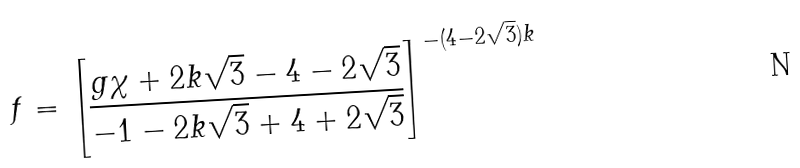<formula> <loc_0><loc_0><loc_500><loc_500>f = \left [ \frac { g \chi + 2 k \sqrt { 3 } - 4 - 2 \sqrt { 3 } } { - 1 - 2 k \sqrt { 3 } + 4 + 2 \sqrt { 3 } } \right ] ^ { - ( 4 - 2 \sqrt { 3 } ) k }</formula> 